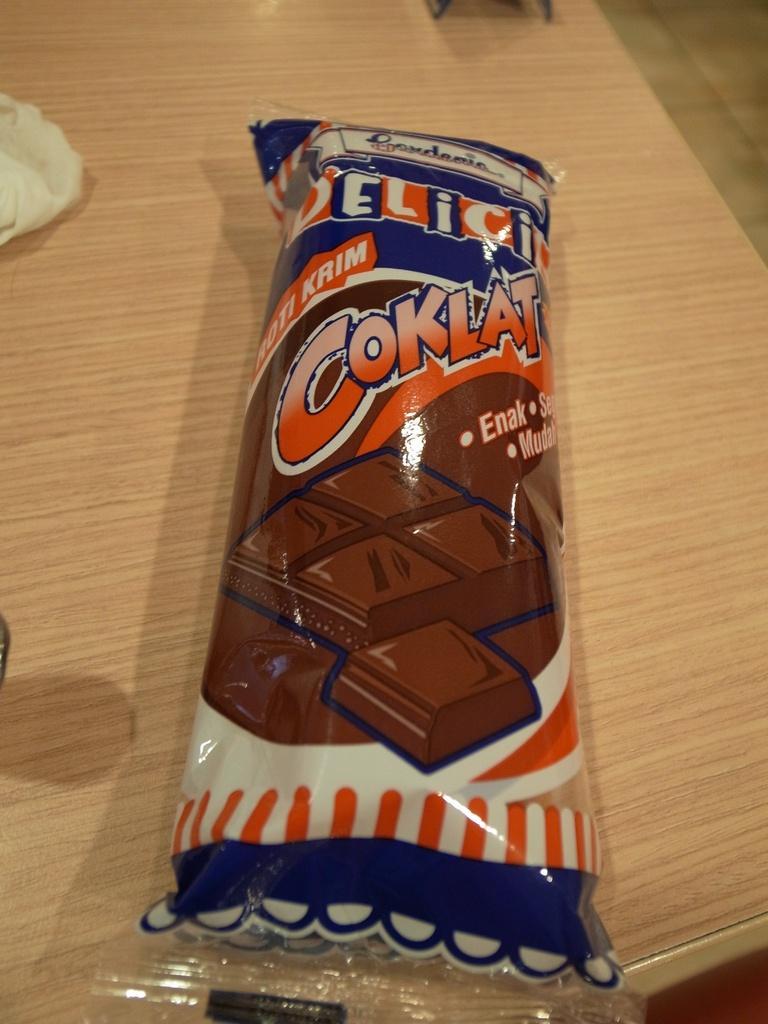Could you give a brief overview of what you see in this image? On this wooden surface we can see a food packet. On this food packet there is a picture of chocolate cubes.   